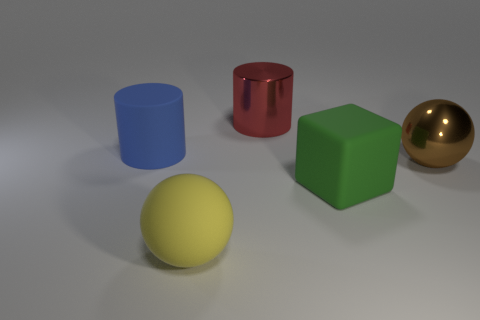Is there a yellow object behind the shiny object behind the big object that is on the left side of the big yellow rubber ball?
Ensure brevity in your answer.  No. What number of metallic cylinders are the same color as the matte sphere?
Your answer should be compact. 0. What is the shape of the brown thing that is the same size as the blue cylinder?
Your answer should be compact. Sphere. Are there any red shiny cylinders right of the green rubber object?
Keep it short and to the point. No. Is the size of the red metallic cylinder the same as the blue matte object?
Offer a very short reply. Yes. There is a big rubber thing that is behind the large green matte thing; what is its shape?
Offer a very short reply. Cylinder. Are there any gray things that have the same size as the brown object?
Your answer should be very brief. No. What is the material of the brown sphere that is the same size as the green block?
Offer a very short reply. Metal. There is a cylinder that is on the left side of the large red thing; how big is it?
Your answer should be very brief. Large. How big is the green block?
Provide a short and direct response. Large. 